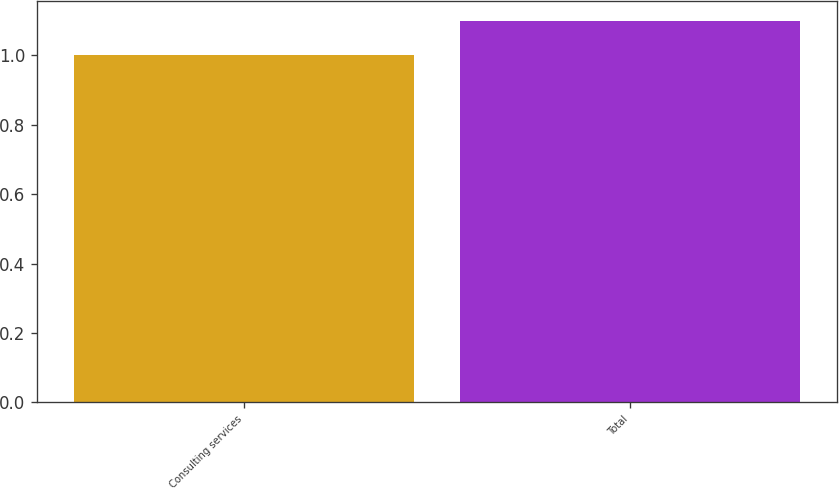Convert chart to OTSL. <chart><loc_0><loc_0><loc_500><loc_500><bar_chart><fcel>Consulting services<fcel>Total<nl><fcel>1<fcel>1.1<nl></chart> 